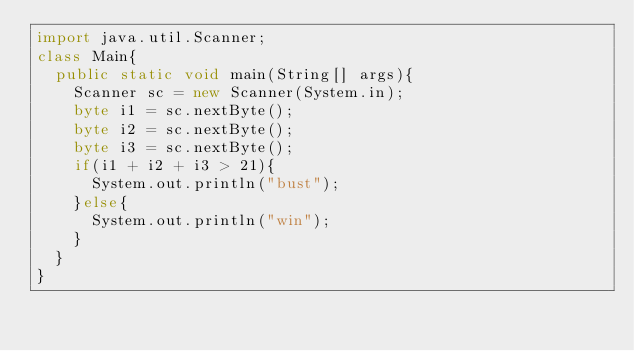<code> <loc_0><loc_0><loc_500><loc_500><_Java_>import java.util.Scanner;
class Main{
  public static void main(String[] args){
    Scanner sc = new Scanner(System.in);
    byte i1 = sc.nextByte();
    byte i2 = sc.nextByte();
    byte i3 = sc.nextByte();
    if(i1 + i2 + i3 > 21){
      System.out.println("bust");
    }else{
      System.out.println("win");
    }
  }
}</code> 